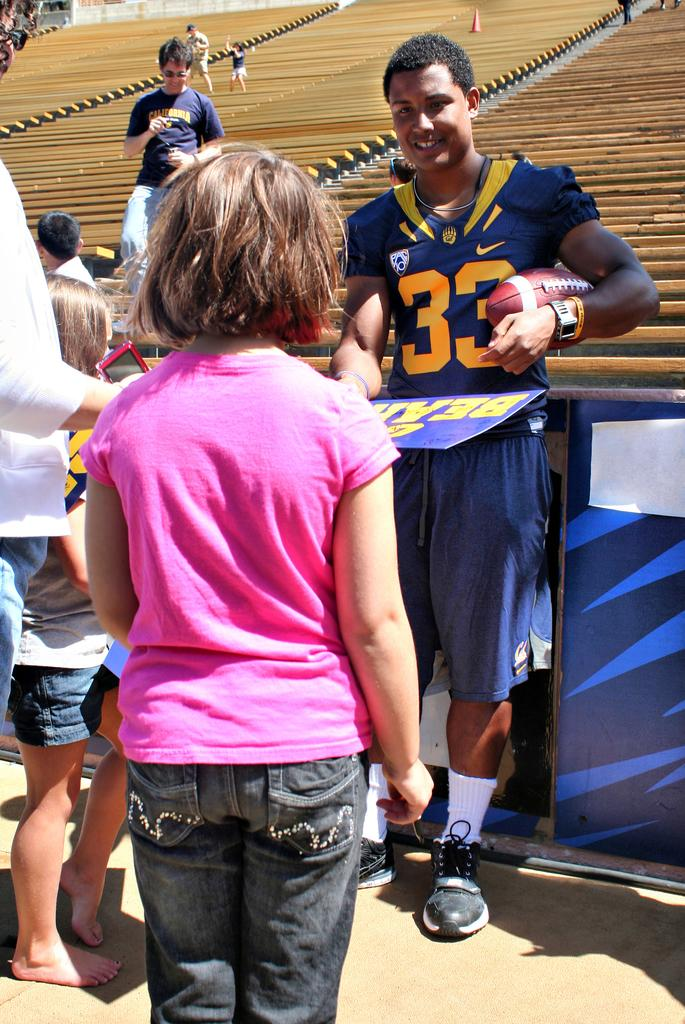<image>
Describe the image concisely. A girl walking up to a football player who is wearing a 33 jersey. 